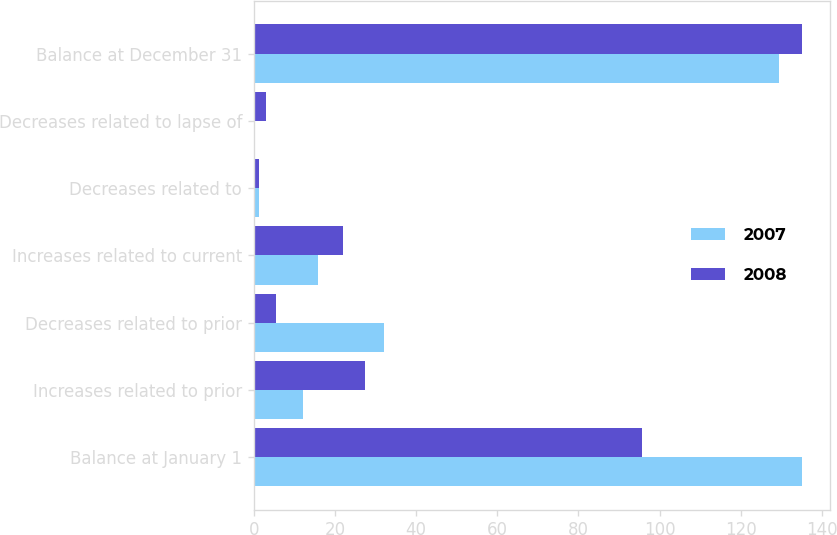Convert chart. <chart><loc_0><loc_0><loc_500><loc_500><stacked_bar_chart><ecel><fcel>Balance at January 1<fcel>Increases related to prior<fcel>Decreases related to prior<fcel>Increases related to current<fcel>Decreases related to<fcel>Decreases related to lapse of<fcel>Balance at December 31<nl><fcel>2007<fcel>135.2<fcel>12.1<fcel>32<fcel>15.8<fcel>1.3<fcel>0.3<fcel>129.5<nl><fcel>2008<fcel>95.7<fcel>27.4<fcel>5.5<fcel>21.9<fcel>1.3<fcel>3<fcel>135.2<nl></chart> 